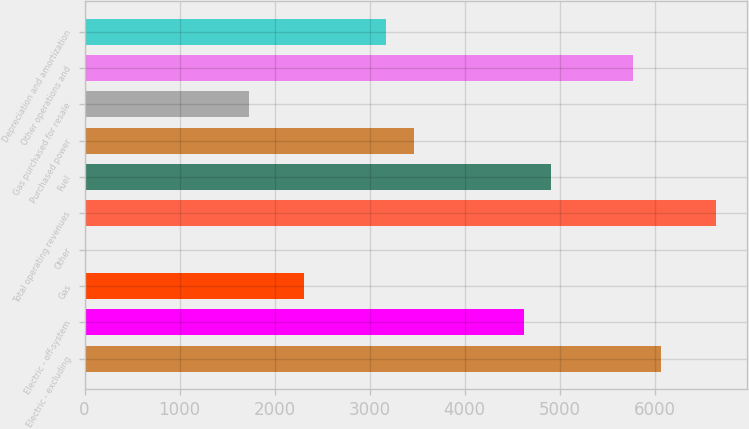Convert chart. <chart><loc_0><loc_0><loc_500><loc_500><bar_chart><fcel>Electric - excluding<fcel>Electric - off-system<fcel>Gas<fcel>Other<fcel>Total operating revenues<fcel>Fuel<fcel>Purchased power<fcel>Gas purchased for resale<fcel>Other operations and<fcel>Depreciation and amortization<nl><fcel>6064.7<fcel>4621.2<fcel>2311.6<fcel>2<fcel>6642.1<fcel>4909.9<fcel>3466.4<fcel>1734.2<fcel>5776<fcel>3177.7<nl></chart> 